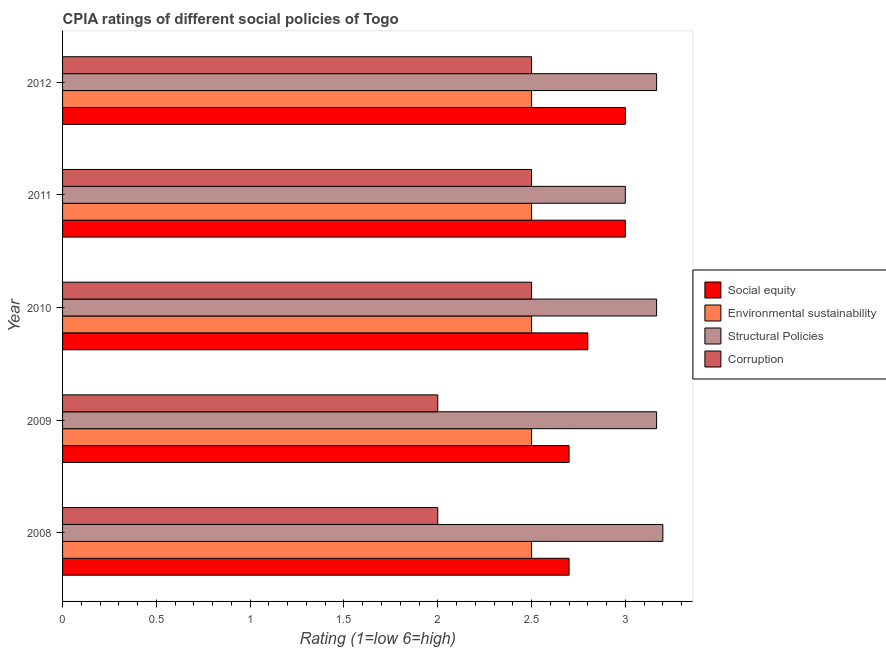How many groups of bars are there?
Offer a terse response. 5. Are the number of bars per tick equal to the number of legend labels?
Provide a short and direct response. Yes. How many bars are there on the 5th tick from the top?
Ensure brevity in your answer.  4. What is the label of the 4th group of bars from the top?
Offer a terse response. 2009. In how many cases, is the number of bars for a given year not equal to the number of legend labels?
Give a very brief answer. 0. In which year was the cpia rating of structural policies maximum?
Your response must be concise. 2008. What is the total cpia rating of social equity in the graph?
Provide a succinct answer. 14.2. What is the difference between the cpia rating of corruption in 2008 and that in 2009?
Offer a very short reply. 0. What is the difference between the cpia rating of environmental sustainability in 2010 and the cpia rating of social equity in 2012?
Keep it short and to the point. -0.5. What is the average cpia rating of structural policies per year?
Keep it short and to the point. 3.14. In the year 2012, what is the difference between the cpia rating of corruption and cpia rating of social equity?
Offer a terse response. -0.5. In how many years, is the cpia rating of social equity greater than the average cpia rating of social equity taken over all years?
Give a very brief answer. 2. Is the sum of the cpia rating of structural policies in 2009 and 2011 greater than the maximum cpia rating of corruption across all years?
Your answer should be compact. Yes. Is it the case that in every year, the sum of the cpia rating of structural policies and cpia rating of corruption is greater than the sum of cpia rating of environmental sustainability and cpia rating of social equity?
Your answer should be compact. No. What does the 4th bar from the top in 2012 represents?
Provide a short and direct response. Social equity. What does the 4th bar from the bottom in 2009 represents?
Offer a very short reply. Corruption. Are all the bars in the graph horizontal?
Provide a succinct answer. Yes. What is the difference between two consecutive major ticks on the X-axis?
Offer a very short reply. 0.5. Does the graph contain grids?
Give a very brief answer. No. What is the title of the graph?
Your answer should be very brief. CPIA ratings of different social policies of Togo. Does "Corruption" appear as one of the legend labels in the graph?
Give a very brief answer. Yes. What is the label or title of the X-axis?
Ensure brevity in your answer.  Rating (1=low 6=high). What is the Rating (1=low 6=high) of Corruption in 2008?
Your answer should be very brief. 2. What is the Rating (1=low 6=high) in Social equity in 2009?
Offer a very short reply. 2.7. What is the Rating (1=low 6=high) of Environmental sustainability in 2009?
Offer a terse response. 2.5. What is the Rating (1=low 6=high) of Structural Policies in 2009?
Offer a very short reply. 3.17. What is the Rating (1=low 6=high) in Corruption in 2009?
Keep it short and to the point. 2. What is the Rating (1=low 6=high) in Structural Policies in 2010?
Provide a short and direct response. 3.17. What is the Rating (1=low 6=high) of Social equity in 2011?
Your response must be concise. 3. What is the Rating (1=low 6=high) in Environmental sustainability in 2012?
Make the answer very short. 2.5. What is the Rating (1=low 6=high) in Structural Policies in 2012?
Your answer should be compact. 3.17. Across all years, what is the maximum Rating (1=low 6=high) in Structural Policies?
Offer a very short reply. 3.2. Across all years, what is the maximum Rating (1=low 6=high) of Corruption?
Make the answer very short. 2.5. Across all years, what is the minimum Rating (1=low 6=high) of Social equity?
Make the answer very short. 2.7. Across all years, what is the minimum Rating (1=low 6=high) of Environmental sustainability?
Your answer should be very brief. 2.5. Across all years, what is the minimum Rating (1=low 6=high) of Structural Policies?
Make the answer very short. 3. Across all years, what is the minimum Rating (1=low 6=high) in Corruption?
Ensure brevity in your answer.  2. What is the total Rating (1=low 6=high) of Structural Policies in the graph?
Keep it short and to the point. 15.7. What is the difference between the Rating (1=low 6=high) in Environmental sustainability in 2008 and that in 2009?
Your answer should be very brief. 0. What is the difference between the Rating (1=low 6=high) in Structural Policies in 2008 and that in 2009?
Offer a very short reply. 0.03. What is the difference between the Rating (1=low 6=high) in Corruption in 2008 and that in 2009?
Give a very brief answer. 0. What is the difference between the Rating (1=low 6=high) in Social equity in 2008 and that in 2010?
Your answer should be compact. -0.1. What is the difference between the Rating (1=low 6=high) of Corruption in 2008 and that in 2010?
Keep it short and to the point. -0.5. What is the difference between the Rating (1=low 6=high) in Environmental sustainability in 2008 and that in 2011?
Provide a succinct answer. 0. What is the difference between the Rating (1=low 6=high) in Social equity in 2008 and that in 2012?
Make the answer very short. -0.3. What is the difference between the Rating (1=low 6=high) of Environmental sustainability in 2008 and that in 2012?
Make the answer very short. 0. What is the difference between the Rating (1=low 6=high) in Social equity in 2009 and that in 2010?
Offer a very short reply. -0.1. What is the difference between the Rating (1=low 6=high) of Corruption in 2009 and that in 2010?
Give a very brief answer. -0.5. What is the difference between the Rating (1=low 6=high) of Social equity in 2009 and that in 2011?
Offer a terse response. -0.3. What is the difference between the Rating (1=low 6=high) of Environmental sustainability in 2009 and that in 2011?
Your answer should be compact. 0. What is the difference between the Rating (1=low 6=high) in Structural Policies in 2009 and that in 2011?
Your response must be concise. 0.17. What is the difference between the Rating (1=low 6=high) in Corruption in 2009 and that in 2011?
Keep it short and to the point. -0.5. What is the difference between the Rating (1=low 6=high) in Social equity in 2009 and that in 2012?
Your answer should be very brief. -0.3. What is the difference between the Rating (1=low 6=high) in Environmental sustainability in 2009 and that in 2012?
Provide a short and direct response. 0. What is the difference between the Rating (1=low 6=high) of Social equity in 2010 and that in 2011?
Your answer should be compact. -0.2. What is the difference between the Rating (1=low 6=high) in Structural Policies in 2010 and that in 2011?
Your answer should be very brief. 0.17. What is the difference between the Rating (1=low 6=high) of Social equity in 2010 and that in 2012?
Your answer should be compact. -0.2. What is the difference between the Rating (1=low 6=high) in Structural Policies in 2010 and that in 2012?
Provide a short and direct response. 0. What is the difference between the Rating (1=low 6=high) in Corruption in 2010 and that in 2012?
Provide a succinct answer. 0. What is the difference between the Rating (1=low 6=high) in Environmental sustainability in 2011 and that in 2012?
Offer a terse response. 0. What is the difference between the Rating (1=low 6=high) of Social equity in 2008 and the Rating (1=low 6=high) of Structural Policies in 2009?
Provide a short and direct response. -0.47. What is the difference between the Rating (1=low 6=high) of Social equity in 2008 and the Rating (1=low 6=high) of Corruption in 2009?
Your answer should be compact. 0.7. What is the difference between the Rating (1=low 6=high) of Structural Policies in 2008 and the Rating (1=low 6=high) of Corruption in 2009?
Your answer should be very brief. 1.2. What is the difference between the Rating (1=low 6=high) in Social equity in 2008 and the Rating (1=low 6=high) in Environmental sustainability in 2010?
Keep it short and to the point. 0.2. What is the difference between the Rating (1=low 6=high) in Social equity in 2008 and the Rating (1=low 6=high) in Structural Policies in 2010?
Ensure brevity in your answer.  -0.47. What is the difference between the Rating (1=low 6=high) in Environmental sustainability in 2008 and the Rating (1=low 6=high) in Corruption in 2010?
Ensure brevity in your answer.  0. What is the difference between the Rating (1=low 6=high) of Structural Policies in 2008 and the Rating (1=low 6=high) of Corruption in 2010?
Give a very brief answer. 0.7. What is the difference between the Rating (1=low 6=high) in Social equity in 2008 and the Rating (1=low 6=high) in Environmental sustainability in 2011?
Offer a terse response. 0.2. What is the difference between the Rating (1=low 6=high) in Social equity in 2008 and the Rating (1=low 6=high) in Corruption in 2011?
Your response must be concise. 0.2. What is the difference between the Rating (1=low 6=high) of Environmental sustainability in 2008 and the Rating (1=low 6=high) of Corruption in 2011?
Make the answer very short. 0. What is the difference between the Rating (1=low 6=high) of Structural Policies in 2008 and the Rating (1=low 6=high) of Corruption in 2011?
Provide a succinct answer. 0.7. What is the difference between the Rating (1=low 6=high) of Social equity in 2008 and the Rating (1=low 6=high) of Structural Policies in 2012?
Your answer should be compact. -0.47. What is the difference between the Rating (1=low 6=high) of Social equity in 2008 and the Rating (1=low 6=high) of Corruption in 2012?
Your response must be concise. 0.2. What is the difference between the Rating (1=low 6=high) in Environmental sustainability in 2008 and the Rating (1=low 6=high) in Structural Policies in 2012?
Provide a succinct answer. -0.67. What is the difference between the Rating (1=low 6=high) in Structural Policies in 2008 and the Rating (1=low 6=high) in Corruption in 2012?
Your answer should be compact. 0.7. What is the difference between the Rating (1=low 6=high) of Social equity in 2009 and the Rating (1=low 6=high) of Environmental sustainability in 2010?
Make the answer very short. 0.2. What is the difference between the Rating (1=low 6=high) in Social equity in 2009 and the Rating (1=low 6=high) in Structural Policies in 2010?
Your answer should be compact. -0.47. What is the difference between the Rating (1=low 6=high) in Environmental sustainability in 2009 and the Rating (1=low 6=high) in Structural Policies in 2010?
Provide a succinct answer. -0.67. What is the difference between the Rating (1=low 6=high) of Social equity in 2009 and the Rating (1=low 6=high) of Structural Policies in 2011?
Ensure brevity in your answer.  -0.3. What is the difference between the Rating (1=low 6=high) of Social equity in 2009 and the Rating (1=low 6=high) of Corruption in 2011?
Your answer should be very brief. 0.2. What is the difference between the Rating (1=low 6=high) in Environmental sustainability in 2009 and the Rating (1=low 6=high) in Structural Policies in 2011?
Make the answer very short. -0.5. What is the difference between the Rating (1=low 6=high) in Environmental sustainability in 2009 and the Rating (1=low 6=high) in Corruption in 2011?
Your response must be concise. 0. What is the difference between the Rating (1=low 6=high) in Structural Policies in 2009 and the Rating (1=low 6=high) in Corruption in 2011?
Your answer should be very brief. 0.67. What is the difference between the Rating (1=low 6=high) in Social equity in 2009 and the Rating (1=low 6=high) in Environmental sustainability in 2012?
Make the answer very short. 0.2. What is the difference between the Rating (1=low 6=high) in Social equity in 2009 and the Rating (1=low 6=high) in Structural Policies in 2012?
Make the answer very short. -0.47. What is the difference between the Rating (1=low 6=high) of Social equity in 2009 and the Rating (1=low 6=high) of Corruption in 2012?
Make the answer very short. 0.2. What is the difference between the Rating (1=low 6=high) in Environmental sustainability in 2009 and the Rating (1=low 6=high) in Corruption in 2012?
Make the answer very short. 0. What is the difference between the Rating (1=low 6=high) in Social equity in 2010 and the Rating (1=low 6=high) in Environmental sustainability in 2011?
Make the answer very short. 0.3. What is the difference between the Rating (1=low 6=high) in Social equity in 2010 and the Rating (1=low 6=high) in Structural Policies in 2011?
Ensure brevity in your answer.  -0.2. What is the difference between the Rating (1=low 6=high) of Social equity in 2010 and the Rating (1=low 6=high) of Corruption in 2011?
Keep it short and to the point. 0.3. What is the difference between the Rating (1=low 6=high) of Environmental sustainability in 2010 and the Rating (1=low 6=high) of Structural Policies in 2011?
Keep it short and to the point. -0.5. What is the difference between the Rating (1=low 6=high) of Environmental sustainability in 2010 and the Rating (1=low 6=high) of Corruption in 2011?
Your answer should be very brief. 0. What is the difference between the Rating (1=low 6=high) of Social equity in 2010 and the Rating (1=low 6=high) of Environmental sustainability in 2012?
Give a very brief answer. 0.3. What is the difference between the Rating (1=low 6=high) of Social equity in 2010 and the Rating (1=low 6=high) of Structural Policies in 2012?
Your response must be concise. -0.37. What is the difference between the Rating (1=low 6=high) of Environmental sustainability in 2010 and the Rating (1=low 6=high) of Structural Policies in 2012?
Your response must be concise. -0.67. What is the difference between the Rating (1=low 6=high) in Structural Policies in 2010 and the Rating (1=low 6=high) in Corruption in 2012?
Offer a very short reply. 0.67. What is the difference between the Rating (1=low 6=high) of Social equity in 2011 and the Rating (1=low 6=high) of Structural Policies in 2012?
Ensure brevity in your answer.  -0.17. What is the difference between the Rating (1=low 6=high) in Social equity in 2011 and the Rating (1=low 6=high) in Corruption in 2012?
Ensure brevity in your answer.  0.5. What is the difference between the Rating (1=low 6=high) in Environmental sustainability in 2011 and the Rating (1=low 6=high) in Corruption in 2012?
Make the answer very short. 0. What is the average Rating (1=low 6=high) of Social equity per year?
Your response must be concise. 2.84. What is the average Rating (1=low 6=high) in Environmental sustainability per year?
Your answer should be very brief. 2.5. What is the average Rating (1=low 6=high) of Structural Policies per year?
Keep it short and to the point. 3.14. What is the average Rating (1=low 6=high) of Corruption per year?
Make the answer very short. 2.3. In the year 2008, what is the difference between the Rating (1=low 6=high) of Environmental sustainability and Rating (1=low 6=high) of Corruption?
Your response must be concise. 0.5. In the year 2009, what is the difference between the Rating (1=low 6=high) in Social equity and Rating (1=low 6=high) in Structural Policies?
Your response must be concise. -0.47. In the year 2009, what is the difference between the Rating (1=low 6=high) in Environmental sustainability and Rating (1=low 6=high) in Structural Policies?
Make the answer very short. -0.67. In the year 2010, what is the difference between the Rating (1=low 6=high) of Social equity and Rating (1=low 6=high) of Structural Policies?
Provide a succinct answer. -0.37. In the year 2010, what is the difference between the Rating (1=low 6=high) in Environmental sustainability and Rating (1=low 6=high) in Structural Policies?
Make the answer very short. -0.67. In the year 2010, what is the difference between the Rating (1=low 6=high) of Environmental sustainability and Rating (1=low 6=high) of Corruption?
Your response must be concise. 0. In the year 2010, what is the difference between the Rating (1=low 6=high) of Structural Policies and Rating (1=low 6=high) of Corruption?
Your answer should be very brief. 0.67. In the year 2011, what is the difference between the Rating (1=low 6=high) of Social equity and Rating (1=low 6=high) of Environmental sustainability?
Ensure brevity in your answer.  0.5. In the year 2011, what is the difference between the Rating (1=low 6=high) of Social equity and Rating (1=low 6=high) of Structural Policies?
Your answer should be very brief. 0. In the year 2011, what is the difference between the Rating (1=low 6=high) of Environmental sustainability and Rating (1=low 6=high) of Structural Policies?
Your answer should be very brief. -0.5. In the year 2011, what is the difference between the Rating (1=low 6=high) of Environmental sustainability and Rating (1=low 6=high) of Corruption?
Offer a very short reply. 0. In the year 2011, what is the difference between the Rating (1=low 6=high) in Structural Policies and Rating (1=low 6=high) in Corruption?
Make the answer very short. 0.5. In the year 2012, what is the difference between the Rating (1=low 6=high) in Social equity and Rating (1=low 6=high) in Environmental sustainability?
Keep it short and to the point. 0.5. In the year 2012, what is the difference between the Rating (1=low 6=high) in Environmental sustainability and Rating (1=low 6=high) in Corruption?
Offer a terse response. 0. What is the ratio of the Rating (1=low 6=high) of Structural Policies in 2008 to that in 2009?
Offer a very short reply. 1.01. What is the ratio of the Rating (1=low 6=high) of Corruption in 2008 to that in 2009?
Keep it short and to the point. 1. What is the ratio of the Rating (1=low 6=high) of Social equity in 2008 to that in 2010?
Your answer should be compact. 0.96. What is the ratio of the Rating (1=low 6=high) in Structural Policies in 2008 to that in 2010?
Keep it short and to the point. 1.01. What is the ratio of the Rating (1=low 6=high) of Corruption in 2008 to that in 2010?
Your answer should be very brief. 0.8. What is the ratio of the Rating (1=low 6=high) of Social equity in 2008 to that in 2011?
Your answer should be very brief. 0.9. What is the ratio of the Rating (1=low 6=high) in Structural Policies in 2008 to that in 2011?
Your answer should be very brief. 1.07. What is the ratio of the Rating (1=low 6=high) of Environmental sustainability in 2008 to that in 2012?
Your response must be concise. 1. What is the ratio of the Rating (1=low 6=high) in Structural Policies in 2008 to that in 2012?
Offer a very short reply. 1.01. What is the ratio of the Rating (1=low 6=high) of Corruption in 2008 to that in 2012?
Provide a short and direct response. 0.8. What is the ratio of the Rating (1=low 6=high) in Structural Policies in 2009 to that in 2010?
Provide a short and direct response. 1. What is the ratio of the Rating (1=low 6=high) in Corruption in 2009 to that in 2010?
Your answer should be compact. 0.8. What is the ratio of the Rating (1=low 6=high) of Environmental sustainability in 2009 to that in 2011?
Give a very brief answer. 1. What is the ratio of the Rating (1=low 6=high) in Structural Policies in 2009 to that in 2011?
Offer a very short reply. 1.06. What is the ratio of the Rating (1=low 6=high) in Social equity in 2009 to that in 2012?
Your response must be concise. 0.9. What is the ratio of the Rating (1=low 6=high) of Environmental sustainability in 2009 to that in 2012?
Offer a terse response. 1. What is the ratio of the Rating (1=low 6=high) of Social equity in 2010 to that in 2011?
Provide a succinct answer. 0.93. What is the ratio of the Rating (1=low 6=high) of Structural Policies in 2010 to that in 2011?
Your response must be concise. 1.06. What is the ratio of the Rating (1=low 6=high) of Structural Policies in 2010 to that in 2012?
Your answer should be very brief. 1. What is the ratio of the Rating (1=low 6=high) of Environmental sustainability in 2011 to that in 2012?
Your response must be concise. 1. What is the ratio of the Rating (1=low 6=high) of Corruption in 2011 to that in 2012?
Offer a terse response. 1. What is the difference between the highest and the second highest Rating (1=low 6=high) in Structural Policies?
Offer a very short reply. 0.03. What is the difference between the highest and the second highest Rating (1=low 6=high) of Corruption?
Give a very brief answer. 0. What is the difference between the highest and the lowest Rating (1=low 6=high) in Social equity?
Make the answer very short. 0.3. What is the difference between the highest and the lowest Rating (1=low 6=high) in Environmental sustainability?
Your answer should be very brief. 0. What is the difference between the highest and the lowest Rating (1=low 6=high) in Structural Policies?
Ensure brevity in your answer.  0.2. 